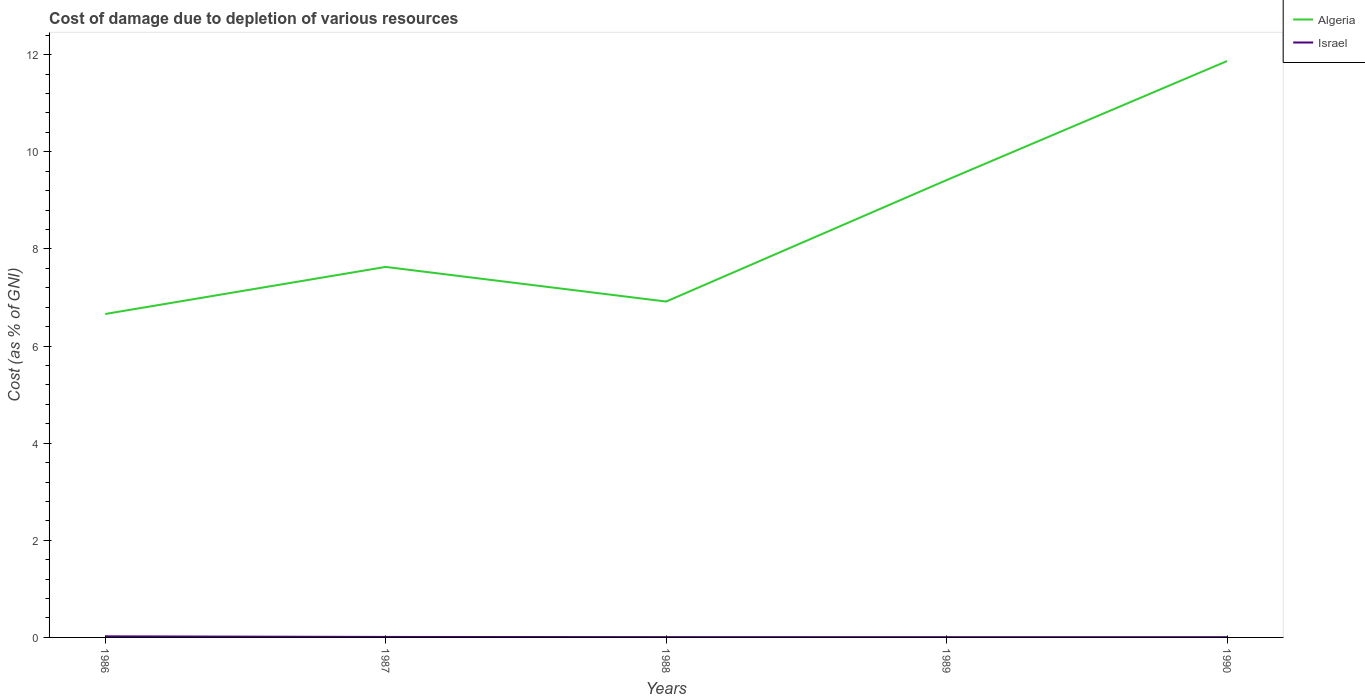Across all years, what is the maximum cost of damage caused due to the depletion of various resources in Israel?
Make the answer very short. 0.01. In which year was the cost of damage caused due to the depletion of various resources in Israel maximum?
Offer a very short reply. 1990. What is the total cost of damage caused due to the depletion of various resources in Israel in the graph?
Ensure brevity in your answer.  0. What is the difference between the highest and the second highest cost of damage caused due to the depletion of various resources in Algeria?
Your answer should be very brief. 5.21. How many lines are there?
Keep it short and to the point. 2. How many years are there in the graph?
Make the answer very short. 5. What is the difference between two consecutive major ticks on the Y-axis?
Offer a very short reply. 2. What is the title of the graph?
Make the answer very short. Cost of damage due to depletion of various resources. What is the label or title of the X-axis?
Keep it short and to the point. Years. What is the label or title of the Y-axis?
Keep it short and to the point. Cost (as % of GNI). What is the Cost (as % of GNI) in Algeria in 1986?
Keep it short and to the point. 6.66. What is the Cost (as % of GNI) of Israel in 1986?
Ensure brevity in your answer.  0.02. What is the Cost (as % of GNI) in Algeria in 1987?
Ensure brevity in your answer.  7.63. What is the Cost (as % of GNI) in Israel in 1987?
Your response must be concise. 0.01. What is the Cost (as % of GNI) in Algeria in 1988?
Offer a very short reply. 6.92. What is the Cost (as % of GNI) in Israel in 1988?
Provide a short and direct response. 0.01. What is the Cost (as % of GNI) of Algeria in 1989?
Offer a very short reply. 9.42. What is the Cost (as % of GNI) of Israel in 1989?
Ensure brevity in your answer.  0.01. What is the Cost (as % of GNI) in Algeria in 1990?
Keep it short and to the point. 11.87. What is the Cost (as % of GNI) of Israel in 1990?
Give a very brief answer. 0.01. Across all years, what is the maximum Cost (as % of GNI) in Algeria?
Offer a very short reply. 11.87. Across all years, what is the maximum Cost (as % of GNI) in Israel?
Provide a succinct answer. 0.02. Across all years, what is the minimum Cost (as % of GNI) of Algeria?
Offer a very short reply. 6.66. Across all years, what is the minimum Cost (as % of GNI) in Israel?
Your answer should be compact. 0.01. What is the total Cost (as % of GNI) in Algeria in the graph?
Your answer should be compact. 42.49. What is the total Cost (as % of GNI) of Israel in the graph?
Make the answer very short. 0.05. What is the difference between the Cost (as % of GNI) in Algeria in 1986 and that in 1987?
Offer a terse response. -0.97. What is the difference between the Cost (as % of GNI) in Israel in 1986 and that in 1987?
Provide a succinct answer. 0.01. What is the difference between the Cost (as % of GNI) in Algeria in 1986 and that in 1988?
Offer a terse response. -0.26. What is the difference between the Cost (as % of GNI) of Israel in 1986 and that in 1988?
Your answer should be very brief. 0.02. What is the difference between the Cost (as % of GNI) of Algeria in 1986 and that in 1989?
Your answer should be very brief. -2.76. What is the difference between the Cost (as % of GNI) in Israel in 1986 and that in 1989?
Offer a very short reply. 0.02. What is the difference between the Cost (as % of GNI) of Algeria in 1986 and that in 1990?
Ensure brevity in your answer.  -5.21. What is the difference between the Cost (as % of GNI) in Israel in 1986 and that in 1990?
Your answer should be very brief. 0.02. What is the difference between the Cost (as % of GNI) of Algeria in 1987 and that in 1988?
Ensure brevity in your answer.  0.71. What is the difference between the Cost (as % of GNI) of Israel in 1987 and that in 1988?
Your response must be concise. 0. What is the difference between the Cost (as % of GNI) of Algeria in 1987 and that in 1989?
Offer a terse response. -1.79. What is the difference between the Cost (as % of GNI) of Israel in 1987 and that in 1989?
Provide a succinct answer. 0. What is the difference between the Cost (as % of GNI) in Algeria in 1987 and that in 1990?
Provide a short and direct response. -4.24. What is the difference between the Cost (as % of GNI) in Israel in 1987 and that in 1990?
Keep it short and to the point. 0. What is the difference between the Cost (as % of GNI) of Algeria in 1988 and that in 1989?
Make the answer very short. -2.5. What is the difference between the Cost (as % of GNI) in Israel in 1988 and that in 1989?
Keep it short and to the point. 0. What is the difference between the Cost (as % of GNI) of Algeria in 1988 and that in 1990?
Offer a terse response. -4.95. What is the difference between the Cost (as % of GNI) of Israel in 1988 and that in 1990?
Your response must be concise. 0. What is the difference between the Cost (as % of GNI) of Algeria in 1989 and that in 1990?
Offer a terse response. -2.45. What is the difference between the Cost (as % of GNI) of Israel in 1989 and that in 1990?
Offer a terse response. 0. What is the difference between the Cost (as % of GNI) in Algeria in 1986 and the Cost (as % of GNI) in Israel in 1987?
Offer a terse response. 6.65. What is the difference between the Cost (as % of GNI) in Algeria in 1986 and the Cost (as % of GNI) in Israel in 1988?
Make the answer very short. 6.65. What is the difference between the Cost (as % of GNI) of Algeria in 1986 and the Cost (as % of GNI) of Israel in 1989?
Offer a very short reply. 6.65. What is the difference between the Cost (as % of GNI) of Algeria in 1986 and the Cost (as % of GNI) of Israel in 1990?
Give a very brief answer. 6.65. What is the difference between the Cost (as % of GNI) in Algeria in 1987 and the Cost (as % of GNI) in Israel in 1988?
Make the answer very short. 7.62. What is the difference between the Cost (as % of GNI) of Algeria in 1987 and the Cost (as % of GNI) of Israel in 1989?
Provide a short and direct response. 7.62. What is the difference between the Cost (as % of GNI) of Algeria in 1987 and the Cost (as % of GNI) of Israel in 1990?
Provide a short and direct response. 7.62. What is the difference between the Cost (as % of GNI) of Algeria in 1988 and the Cost (as % of GNI) of Israel in 1989?
Provide a succinct answer. 6.91. What is the difference between the Cost (as % of GNI) of Algeria in 1988 and the Cost (as % of GNI) of Israel in 1990?
Give a very brief answer. 6.91. What is the difference between the Cost (as % of GNI) of Algeria in 1989 and the Cost (as % of GNI) of Israel in 1990?
Your response must be concise. 9.41. What is the average Cost (as % of GNI) of Algeria per year?
Your answer should be very brief. 8.5. What is the average Cost (as % of GNI) in Israel per year?
Make the answer very short. 0.01. In the year 1986, what is the difference between the Cost (as % of GNI) of Algeria and Cost (as % of GNI) of Israel?
Give a very brief answer. 6.64. In the year 1987, what is the difference between the Cost (as % of GNI) of Algeria and Cost (as % of GNI) of Israel?
Ensure brevity in your answer.  7.62. In the year 1988, what is the difference between the Cost (as % of GNI) in Algeria and Cost (as % of GNI) in Israel?
Give a very brief answer. 6.91. In the year 1989, what is the difference between the Cost (as % of GNI) of Algeria and Cost (as % of GNI) of Israel?
Your answer should be very brief. 9.41. In the year 1990, what is the difference between the Cost (as % of GNI) in Algeria and Cost (as % of GNI) in Israel?
Give a very brief answer. 11.86. What is the ratio of the Cost (as % of GNI) in Algeria in 1986 to that in 1987?
Your answer should be very brief. 0.87. What is the ratio of the Cost (as % of GNI) in Israel in 1986 to that in 1987?
Make the answer very short. 2.2. What is the ratio of the Cost (as % of GNI) in Algeria in 1986 to that in 1988?
Provide a succinct answer. 0.96. What is the ratio of the Cost (as % of GNI) of Israel in 1986 to that in 1988?
Provide a short and direct response. 3.59. What is the ratio of the Cost (as % of GNI) in Algeria in 1986 to that in 1989?
Ensure brevity in your answer.  0.71. What is the ratio of the Cost (as % of GNI) of Israel in 1986 to that in 1989?
Provide a short and direct response. 3.96. What is the ratio of the Cost (as % of GNI) of Algeria in 1986 to that in 1990?
Provide a short and direct response. 0.56. What is the ratio of the Cost (as % of GNI) of Israel in 1986 to that in 1990?
Give a very brief answer. 4.09. What is the ratio of the Cost (as % of GNI) of Algeria in 1987 to that in 1988?
Offer a very short reply. 1.1. What is the ratio of the Cost (as % of GNI) in Israel in 1987 to that in 1988?
Provide a short and direct response. 1.63. What is the ratio of the Cost (as % of GNI) of Algeria in 1987 to that in 1989?
Provide a succinct answer. 0.81. What is the ratio of the Cost (as % of GNI) of Israel in 1987 to that in 1989?
Offer a very short reply. 1.8. What is the ratio of the Cost (as % of GNI) in Algeria in 1987 to that in 1990?
Provide a succinct answer. 0.64. What is the ratio of the Cost (as % of GNI) of Israel in 1987 to that in 1990?
Your answer should be very brief. 1.86. What is the ratio of the Cost (as % of GNI) of Algeria in 1988 to that in 1989?
Your answer should be compact. 0.73. What is the ratio of the Cost (as % of GNI) of Israel in 1988 to that in 1989?
Ensure brevity in your answer.  1.1. What is the ratio of the Cost (as % of GNI) of Algeria in 1988 to that in 1990?
Make the answer very short. 0.58. What is the ratio of the Cost (as % of GNI) in Israel in 1988 to that in 1990?
Your answer should be compact. 1.14. What is the ratio of the Cost (as % of GNI) of Algeria in 1989 to that in 1990?
Ensure brevity in your answer.  0.79. What is the ratio of the Cost (as % of GNI) in Israel in 1989 to that in 1990?
Ensure brevity in your answer.  1.03. What is the difference between the highest and the second highest Cost (as % of GNI) of Algeria?
Offer a very short reply. 2.45. What is the difference between the highest and the second highest Cost (as % of GNI) in Israel?
Make the answer very short. 0.01. What is the difference between the highest and the lowest Cost (as % of GNI) of Algeria?
Your answer should be compact. 5.21. What is the difference between the highest and the lowest Cost (as % of GNI) in Israel?
Your answer should be very brief. 0.02. 